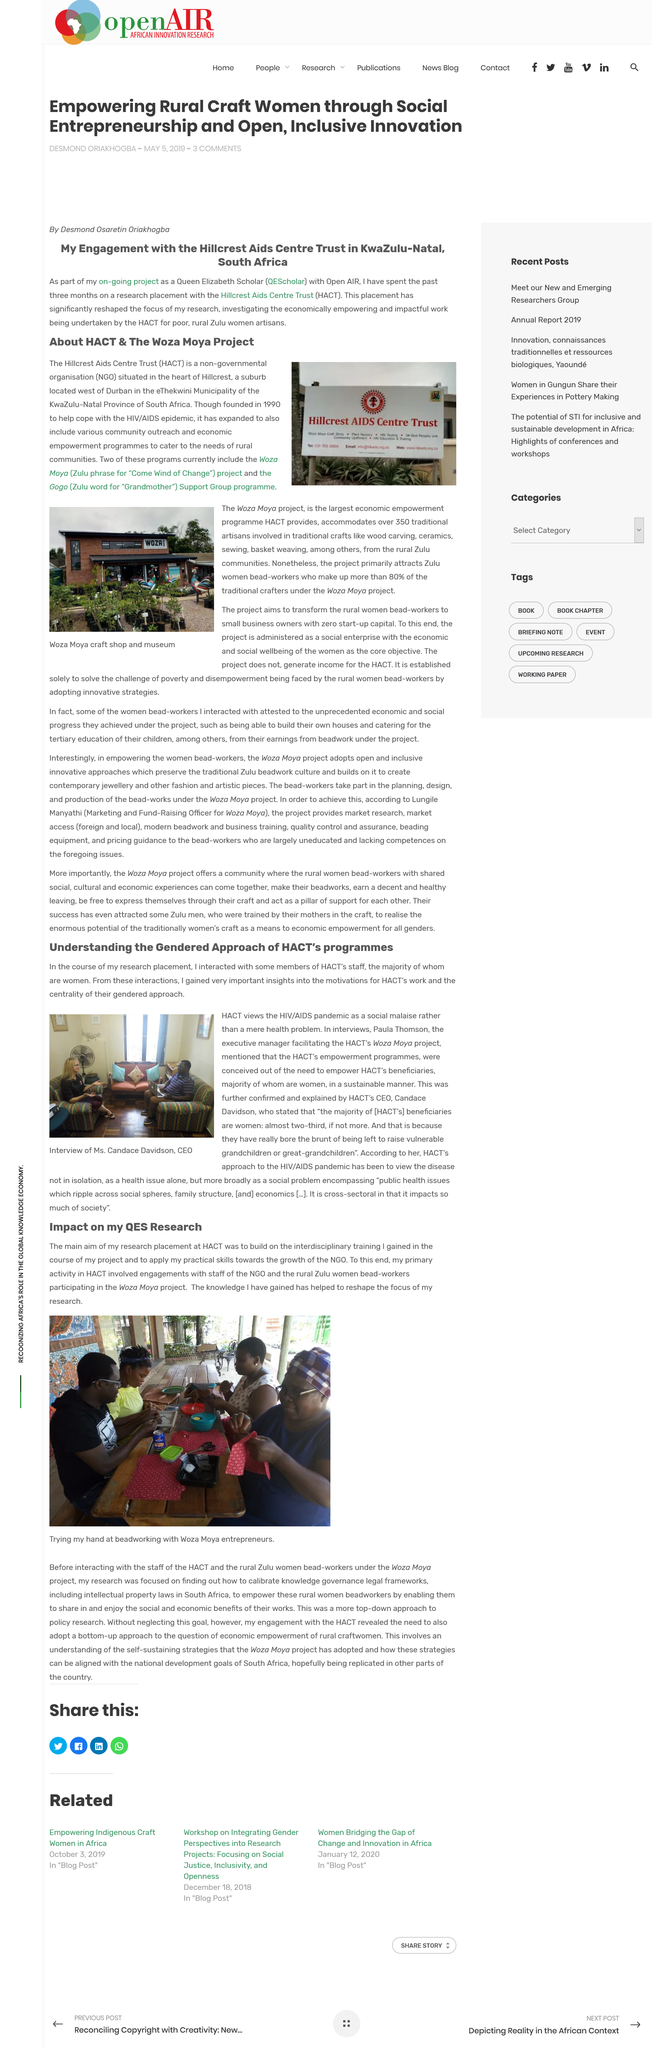Indicate a few pertinent items in this graphic. The Hillcrest Aids Centre Trust is the organisation that is featured on the sign in the photo. HACT is a non-governmental organization. The author's main aim in conducting the research was to utilize the interdisciplinary training acquired and apply the practical skills to contribute to the development of the NGO. Yes, the author's knowledge has significantly influenced the scope and direction of the author's research. HACT was established in 1990. 